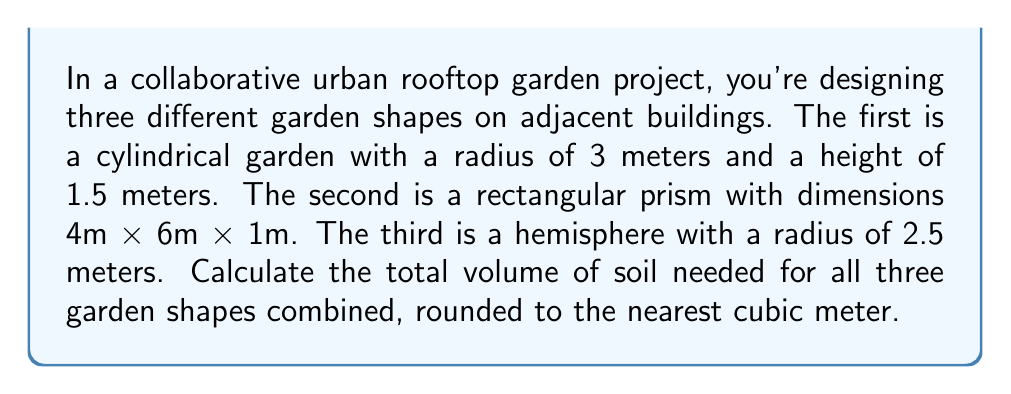Help me with this question. To solve this problem, we need to calculate the volume of each shape and then sum them up:

1. Cylindrical garden:
   Volume of a cylinder: $V = \pi r^2 h$
   $$V_1 = \pi \cdot 3^2 \cdot 1.5 = 42.41 \text{ m}^3$$

2. Rectangular prism garden:
   Volume of a rectangular prism: $V = l \cdot w \cdot h$
   $$V_2 = 4 \cdot 6 \cdot 1 = 24 \text{ m}^3$$

3. Hemispherical garden:
   Volume of a hemisphere: $V = \frac{2}{3}\pi r^3$
   $$V_3 = \frac{2}{3}\pi \cdot 2.5^3 = 32.72 \text{ m}^3$$

Total volume:
$$V_{total} = V_1 + V_2 + V_3 = 42.41 + 24 + 32.72 = 99.13 \text{ m}^3$$

Rounding to the nearest cubic meter:
$$V_{total} \approx 99 \text{ m}^3$$
Answer: 99 m³ 